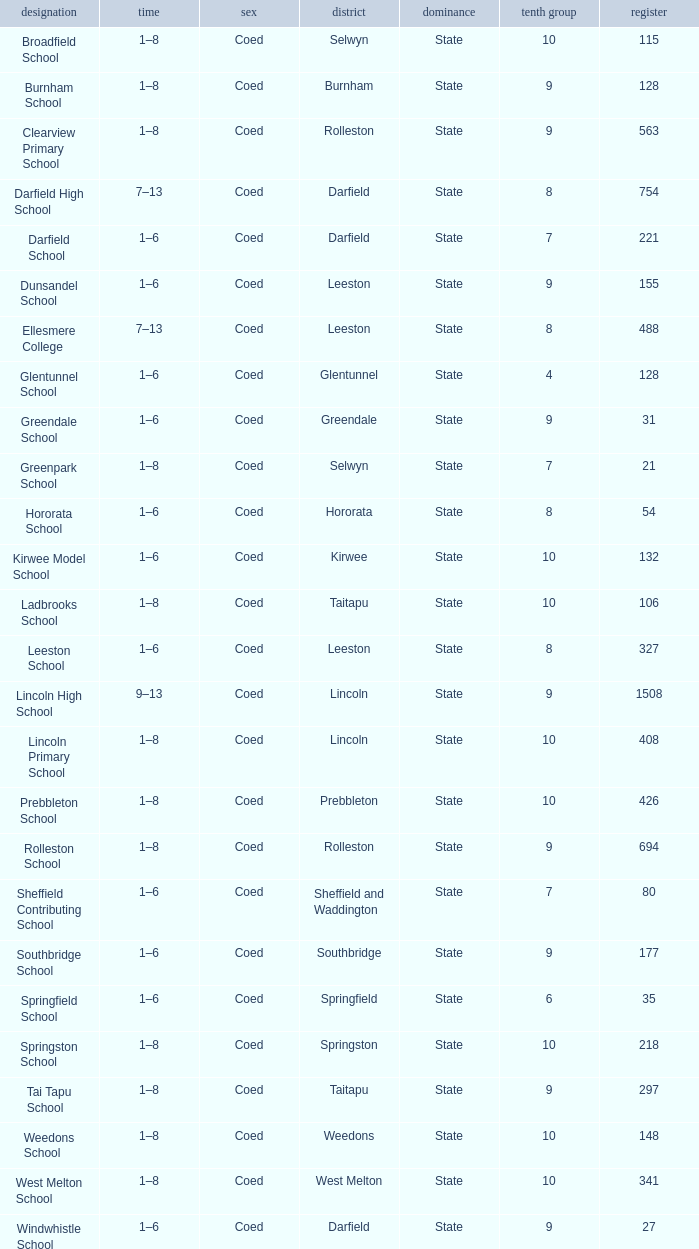What is the name with a Decile less than 10, and a Roll of 297? Tai Tapu School. 